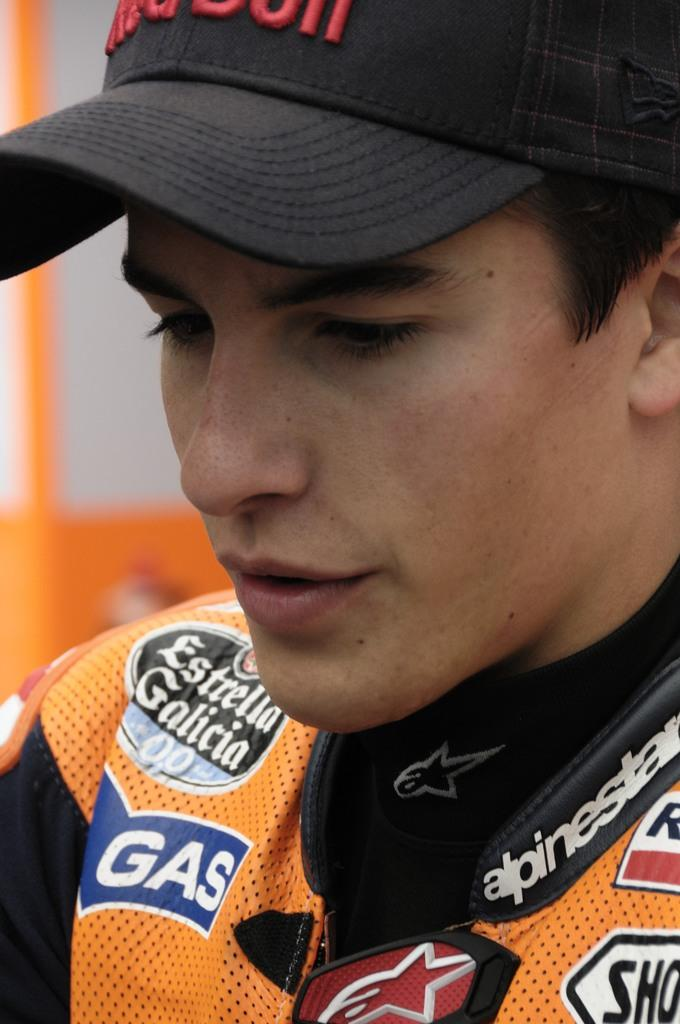<image>
Give a short and clear explanation of the subsequent image. The blue tag on the persons shirt says gas 